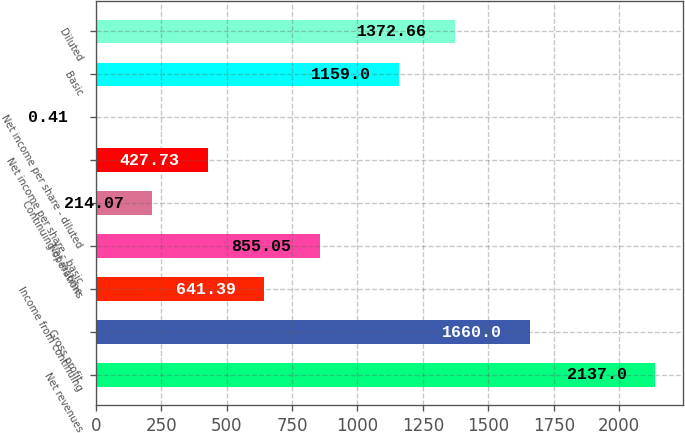<chart> <loc_0><loc_0><loc_500><loc_500><bar_chart><fcel>Net revenues<fcel>Gross profit<fcel>Income from continuing<fcel>Net income<fcel>Continuing operations<fcel>Net income per share - basic<fcel>Net income per share - diluted<fcel>Basic<fcel>Diluted<nl><fcel>2137<fcel>1660<fcel>641.39<fcel>855.05<fcel>214.07<fcel>427.73<fcel>0.41<fcel>1159<fcel>1372.66<nl></chart> 